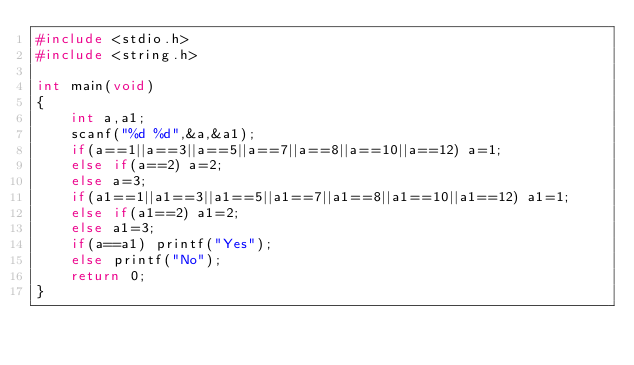Convert code to text. <code><loc_0><loc_0><loc_500><loc_500><_C_>#include <stdio.h>
#include <string.h>

int main(void)
{
    int a,a1;
    scanf("%d %d",&a,&a1);
    if(a==1||a==3||a==5||a==7||a==8||a==10||a==12) a=1;
    else if(a==2) a=2;
    else a=3;
    if(a1==1||a1==3||a1==5||a1==7||a1==8||a1==10||a1==12) a1=1;
    else if(a1==2) a1=2;
    else a1=3;
    if(a==a1) printf("Yes");
    else printf("No");
    return 0;
}
</code> 